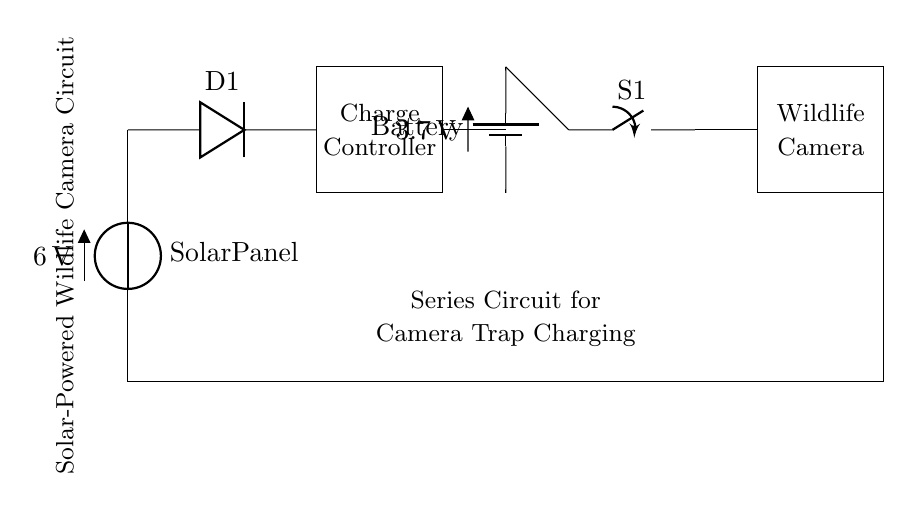What is the voltage of the solar panel? The solar panel has a voltage of 6 volts, as indicated in the circuit diagram.
Answer: 6 volts What is the component labeled D1? D1 is a diode, which allows current to flow in one direction and protects against reverse polarity.
Answer: Diode What is the function of the charge controller? The charge controller manages the voltage and current from the solar panel to charge the battery safely.
Answer: Charge management What is the total voltage of the battery? The battery has a voltage of 3.7 volts, which is labeled next to the battery symbol in the circuit.
Answer: 3.7 volts How is the wildlife camera connected in the circuit? The wildlife camera is connected in series with a switch and the battery, meaning that all components share the same current path.
Answer: In series What could happen if the solar panel voltage exceeds the battery voltage? The diode prevents backflow of current, which would otherwise damage the battery if the solar panel generates a higher voltage than the battery can handle.
Answer: Damage prevention What is the purpose of the switch S1? The switch S1 allows for turning the connection to the wildlife camera on or off, controlling its operation and battery usage.
Answer: On/off control 